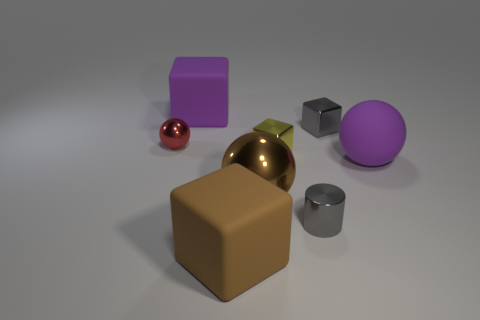There is a small metallic thing that is the same color as the shiny cylinder; what is its shape?
Your answer should be compact. Cube. How many other things are there of the same shape as the small yellow metallic object?
Give a very brief answer. 3. There is a big block in front of the gray shiny object behind the small shiny cylinder; what is it made of?
Provide a succinct answer. Rubber. There is a gray cylinder; are there any rubber objects to the right of it?
Offer a terse response. Yes. Does the metal cylinder have the same size as the cube that is in front of the brown ball?
Make the answer very short. No. The other metallic thing that is the same shape as the big brown metallic object is what size?
Make the answer very short. Small. Is there any other thing that has the same material as the tiny ball?
Give a very brief answer. Yes. Do the gray object that is in front of the small metal ball and the metallic sphere in front of the red thing have the same size?
Keep it short and to the point. No. How many large objects are brown metal spheres or purple shiny things?
Provide a short and direct response. 1. What number of large purple rubber objects are to the right of the yellow thing and on the left side of the tiny cylinder?
Make the answer very short. 0. 